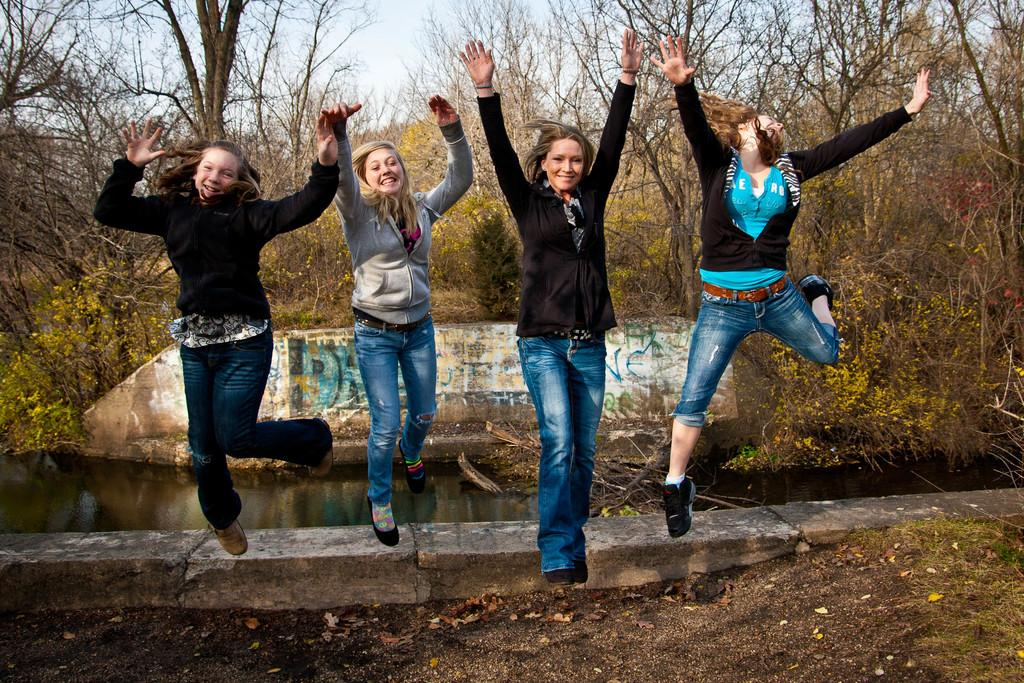How many women are present in the image? There are four women in the image. What is the facial expression of the women? The women are smiling. What can be seen in the background of the image? Water, trees, and the sky are visible in the background of the image. What type of ground surface is present in the image? There is grass in the image. What type of vegetation is present in the image? There are plants in the image. What type of cabbage is being used as a hat by one of the women in the image? There is no cabbage present in the image, nor is any woman wearing a cabbage as a hat. What color is the thread used to sew the toothbrush in the image? There is no toothbrush present in the image, so it is not possible to determine the color of any thread used to sew it. 